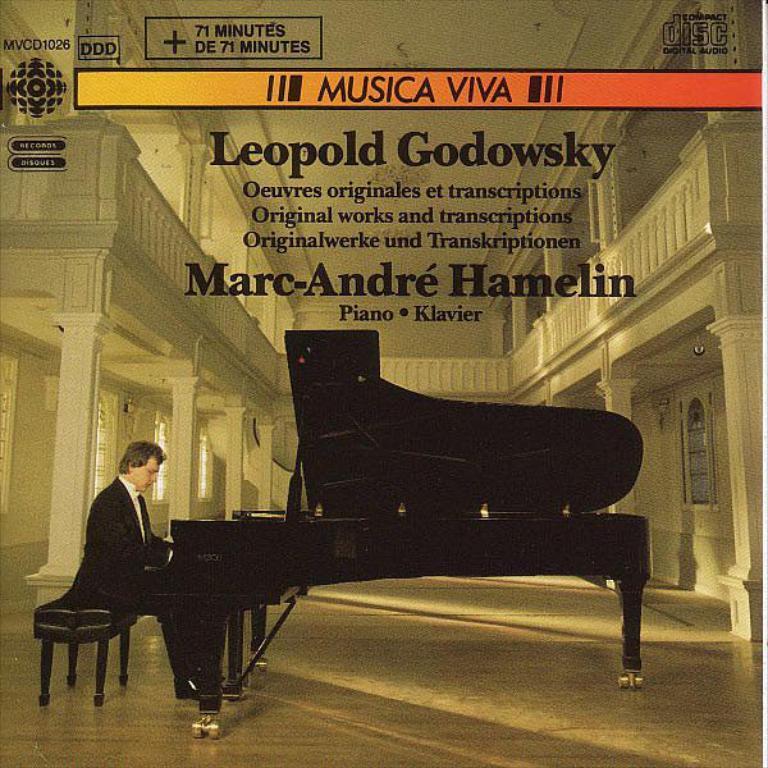How would you summarize this image in a sentence or two? In this image I can see a man is sitting on a bench and playing a piano on the floor. 